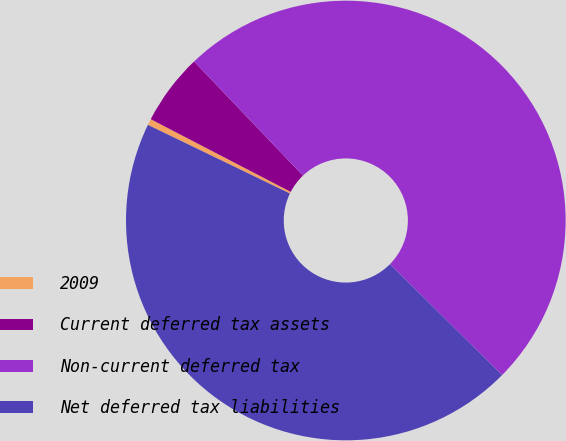<chart> <loc_0><loc_0><loc_500><loc_500><pie_chart><fcel>2009<fcel>Current deferred tax assets<fcel>Non-current deferred tax<fcel>Net deferred tax liabilities<nl><fcel>0.46%<fcel>5.25%<fcel>49.54%<fcel>44.75%<nl></chart> 